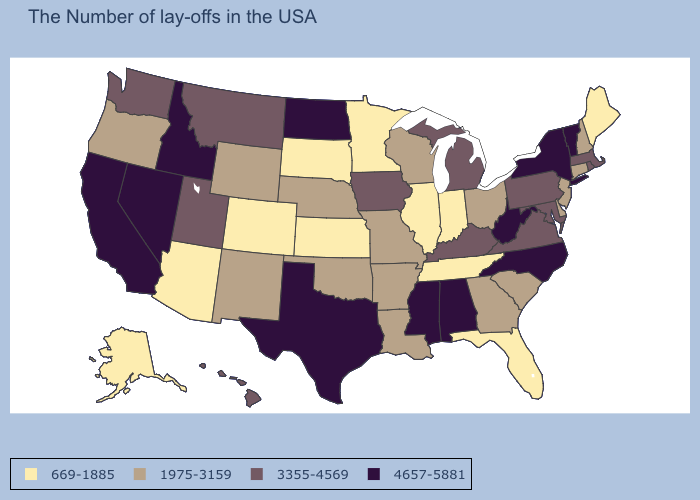Among the states that border Kentucky , which have the lowest value?
Write a very short answer. Indiana, Tennessee, Illinois. Which states have the lowest value in the USA?
Write a very short answer. Maine, Florida, Indiana, Tennessee, Illinois, Minnesota, Kansas, South Dakota, Colorado, Arizona, Alaska. What is the value of Vermont?
Write a very short answer. 4657-5881. What is the value of Wisconsin?
Keep it brief. 1975-3159. What is the value of Montana?
Give a very brief answer. 3355-4569. What is the value of Delaware?
Concise answer only. 1975-3159. What is the value of Missouri?
Short answer required. 1975-3159. What is the value of Virginia?
Short answer required. 3355-4569. Which states have the lowest value in the USA?
Keep it brief. Maine, Florida, Indiana, Tennessee, Illinois, Minnesota, Kansas, South Dakota, Colorado, Arizona, Alaska. Name the states that have a value in the range 669-1885?
Short answer required. Maine, Florida, Indiana, Tennessee, Illinois, Minnesota, Kansas, South Dakota, Colorado, Arizona, Alaska. Among the states that border Tennessee , which have the lowest value?
Be succinct. Georgia, Missouri, Arkansas. Name the states that have a value in the range 4657-5881?
Answer briefly. Vermont, New York, North Carolina, West Virginia, Alabama, Mississippi, Texas, North Dakota, Idaho, Nevada, California. Among the states that border South Dakota , does Nebraska have the highest value?
Write a very short answer. No. What is the lowest value in the USA?
Answer briefly. 669-1885. Name the states that have a value in the range 669-1885?
Answer briefly. Maine, Florida, Indiana, Tennessee, Illinois, Minnesota, Kansas, South Dakota, Colorado, Arizona, Alaska. 